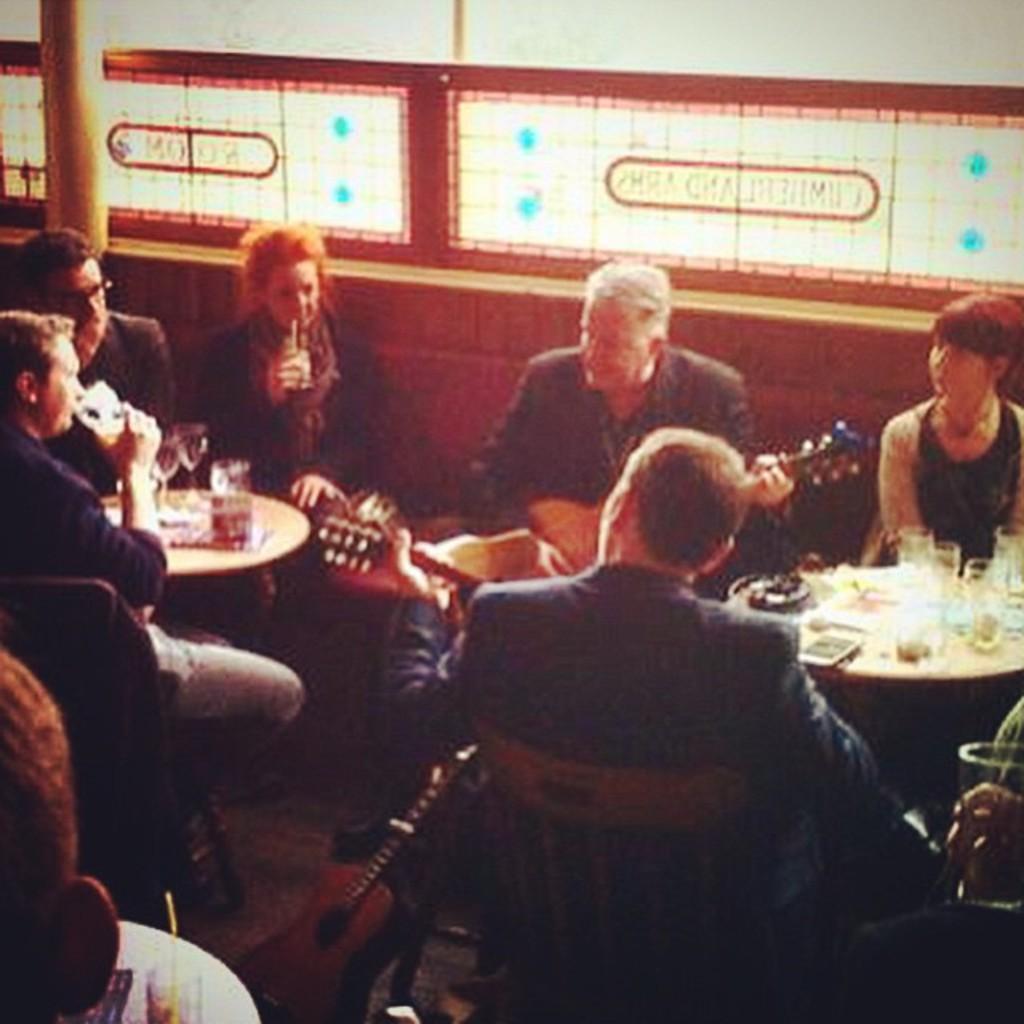Could you give a brief overview of what you see in this image? In this image I can see number of people are sitting on chairs and few people are holding guitars. On this table I can see few glasses. 